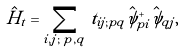<formula> <loc_0><loc_0><loc_500><loc_500>\hat { H } _ { t } = \sum _ { i , j ; \, p , q } t _ { i j ; p q } \hat { \psi } _ { p i } ^ { + } \hat { \psi } _ { q j } ,</formula> 